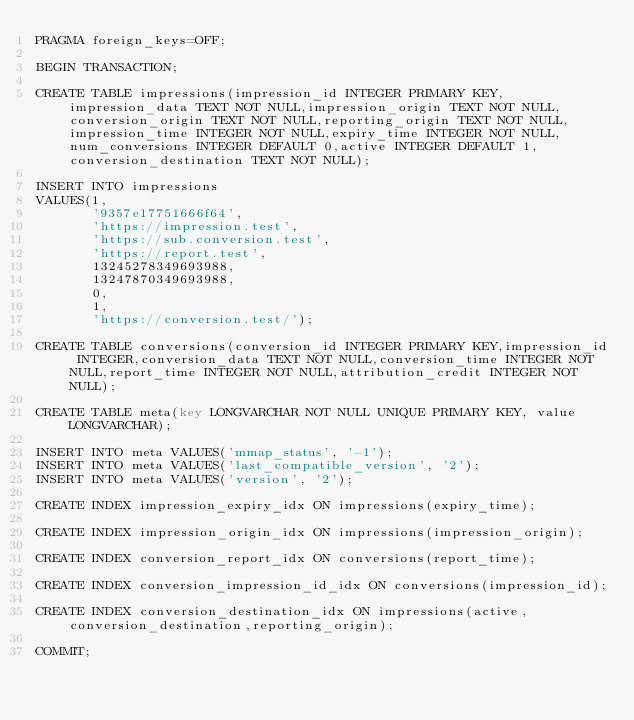<code> <loc_0><loc_0><loc_500><loc_500><_SQL_>PRAGMA foreign_keys=OFF;

BEGIN TRANSACTION;

CREATE TABLE impressions(impression_id INTEGER PRIMARY KEY,impression_data TEXT NOT NULL,impression_origin TEXT NOT NULL,conversion_origin TEXT NOT NULL,reporting_origin TEXT NOT NULL,impression_time INTEGER NOT NULL,expiry_time INTEGER NOT NULL,num_conversions INTEGER DEFAULT 0,active INTEGER DEFAULT 1,conversion_destination TEXT NOT NULL);

INSERT INTO impressions
VALUES(1,
       '9357e17751666f64',
       'https://impression.test',
       'https://sub.conversion.test',
       'https://report.test',
       13245278349693988,
       13247870349693988,
       0,
       1,
       'https://conversion.test/');

CREATE TABLE conversions(conversion_id INTEGER PRIMARY KEY,impression_id INTEGER,conversion_data TEXT NOT NULL,conversion_time INTEGER NOT NULL,report_time INTEGER NOT NULL,attribution_credit INTEGER NOT NULL);

CREATE TABLE meta(key LONGVARCHAR NOT NULL UNIQUE PRIMARY KEY, value LONGVARCHAR);

INSERT INTO meta VALUES('mmap_status', '-1');
INSERT INTO meta VALUES('last_compatible_version', '2');
INSERT INTO meta VALUES('version', '2');

CREATE INDEX impression_expiry_idx ON impressions(expiry_time);

CREATE INDEX impression_origin_idx ON impressions(impression_origin);

CREATE INDEX conversion_report_idx ON conversions(report_time);

CREATE INDEX conversion_impression_id_idx ON conversions(impression_id);

CREATE INDEX conversion_destination_idx ON impressions(active,conversion_destination,reporting_origin);

COMMIT;
</code> 